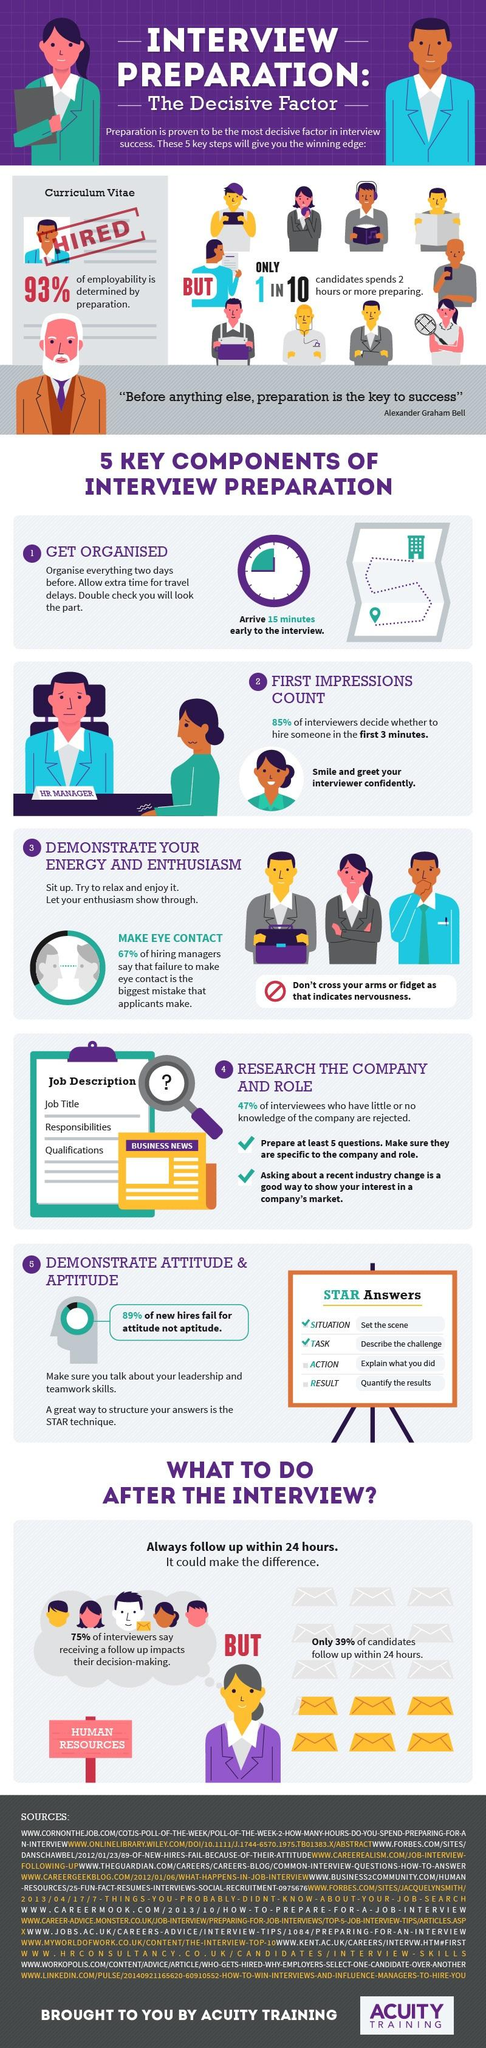Specify some key components in this picture. It is estimated that 11% of interviewees fail due to their aptitude. A recent survey found that 33% of hiring managers disagree that eye contact is an important aspect of an interview. 